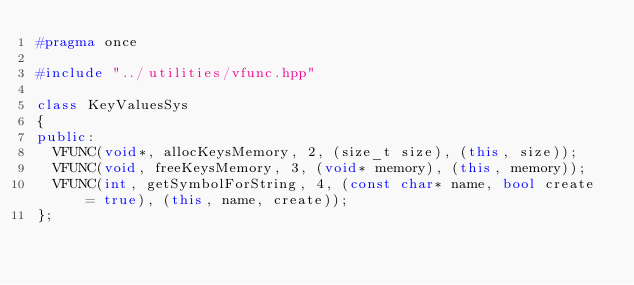<code> <loc_0><loc_0><loc_500><loc_500><_C++_>#pragma once

#include "../utilities/vfunc.hpp"

class KeyValuesSys
{
public:
	VFUNC(void*, allocKeysMemory, 2, (size_t size), (this, size));
	VFUNC(void, freeKeysMemory, 3, (void* memory), (this, memory));
	VFUNC(int, getSymbolForString, 4, (const char* name, bool create = true), (this, name, create));
};</code> 